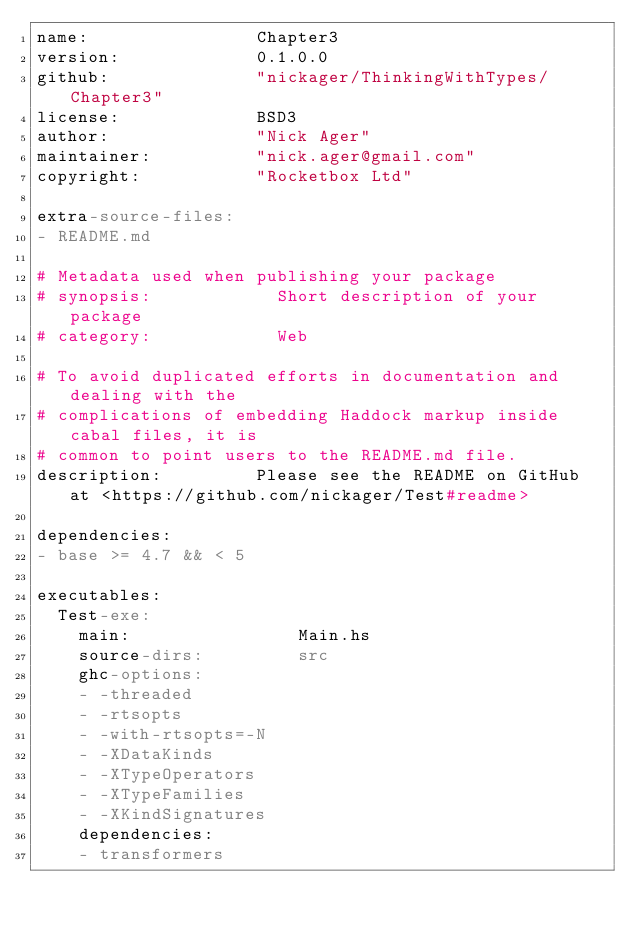<code> <loc_0><loc_0><loc_500><loc_500><_YAML_>name:                Chapter3
version:             0.1.0.0
github:              "nickager/ThinkingWithTypes/Chapter3"
license:             BSD3
author:              "Nick Ager"
maintainer:          "nick.ager@gmail.com"
copyright:           "Rocketbox Ltd"

extra-source-files:
- README.md

# Metadata used when publishing your package
# synopsis:            Short description of your package
# category:            Web

# To avoid duplicated efforts in documentation and dealing with the
# complications of embedding Haddock markup inside cabal files, it is
# common to point users to the README.md file.
description:         Please see the README on GitHub at <https://github.com/nickager/Test#readme>

dependencies:
- base >= 4.7 && < 5

executables:
  Test-exe:
    main:                Main.hs
    source-dirs:         src
    ghc-options:
    - -threaded
    - -rtsopts
    - -with-rtsopts=-N
    - -XDataKinds
    - -XTypeOperators
    - -XTypeFamilies
    - -XKindSignatures
    dependencies:
    - transformers


</code> 